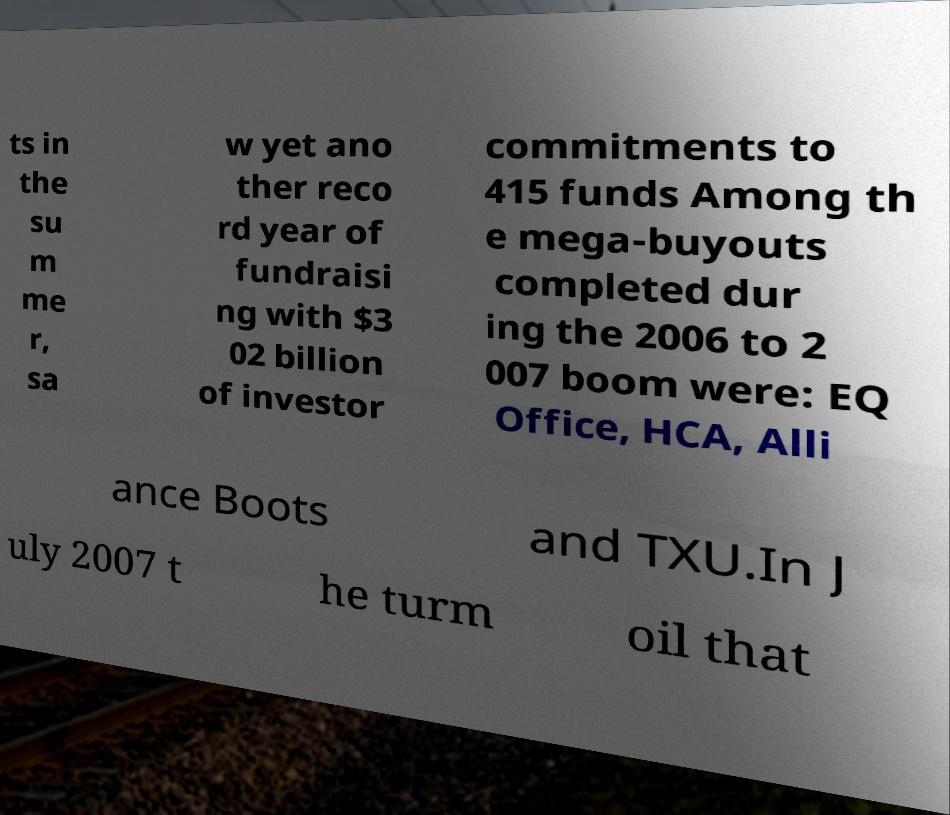I need the written content from this picture converted into text. Can you do that? ts in the su m me r, sa w yet ano ther reco rd year of fundraisi ng with $3 02 billion of investor commitments to 415 funds Among th e mega-buyouts completed dur ing the 2006 to 2 007 boom were: EQ Office, HCA, Alli ance Boots and TXU.In J uly 2007 t he turm oil that 